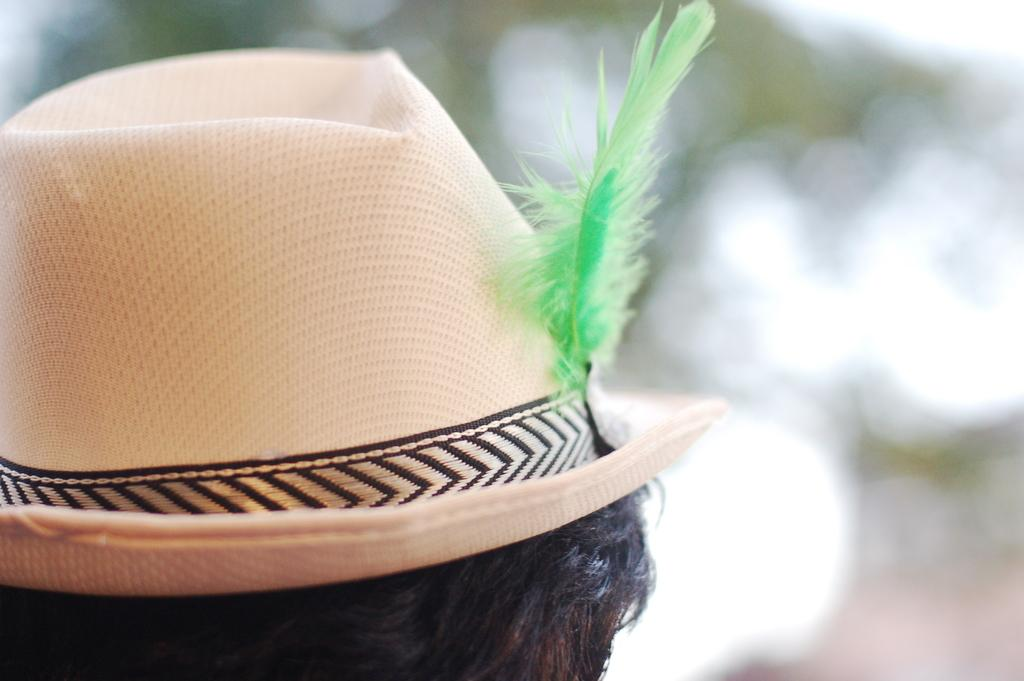What is on the head of the person in the image? There is a hat with a feather in the image. Can you describe the hat in more detail? The hat has a feather attached to it. What can be observed about the background of the image? The background of the image is blurry. How many flies can be seen on the hat in the image? There are no flies present on the hat in the image. 